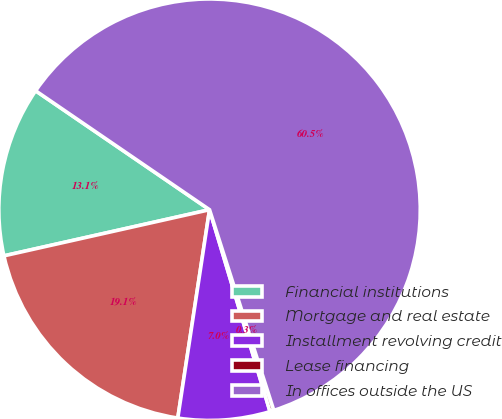Convert chart to OTSL. <chart><loc_0><loc_0><loc_500><loc_500><pie_chart><fcel>Financial institutions<fcel>Mortgage and real estate<fcel>Installment revolving credit<fcel>Lease financing<fcel>In offices outside the US<nl><fcel>13.06%<fcel>19.08%<fcel>7.04%<fcel>0.3%<fcel>60.52%<nl></chart> 